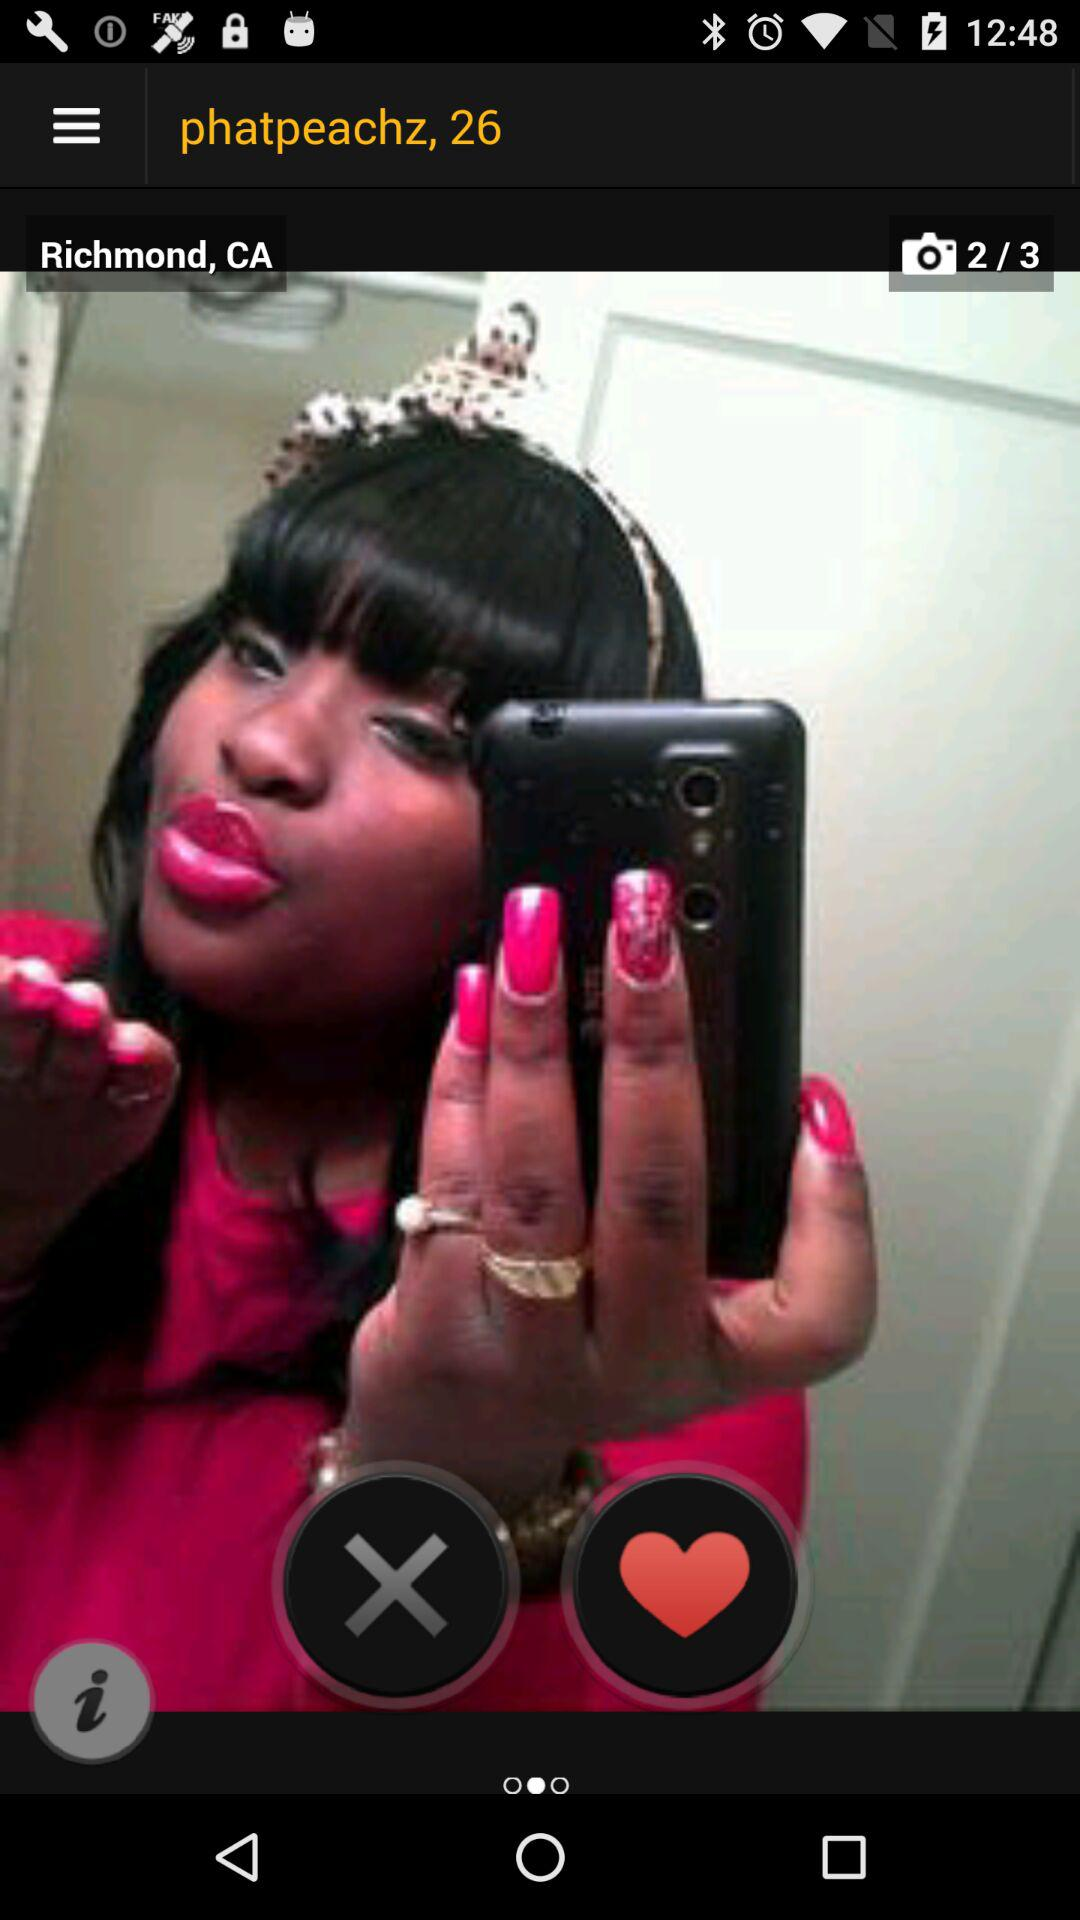What is the total number of photos? The total number of photos is 3. 